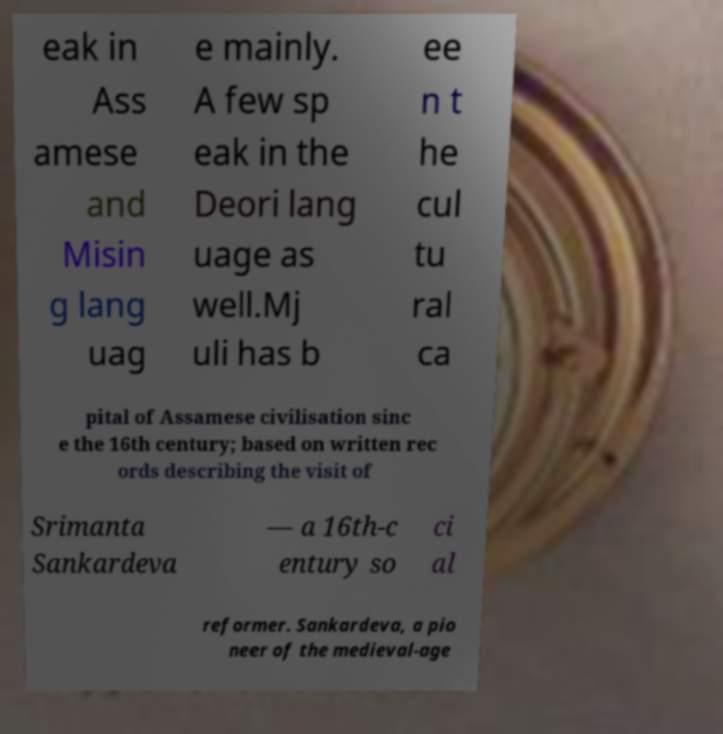What messages or text are displayed in this image? I need them in a readable, typed format. eak in Ass amese and Misin g lang uag e mainly. A few sp eak in the Deori lang uage as well.Mj uli has b ee n t he cul tu ral ca pital of Assamese civilisation sinc e the 16th century; based on written rec ords describing the visit of Srimanta Sankardeva — a 16th-c entury so ci al reformer. Sankardeva, a pio neer of the medieval-age 